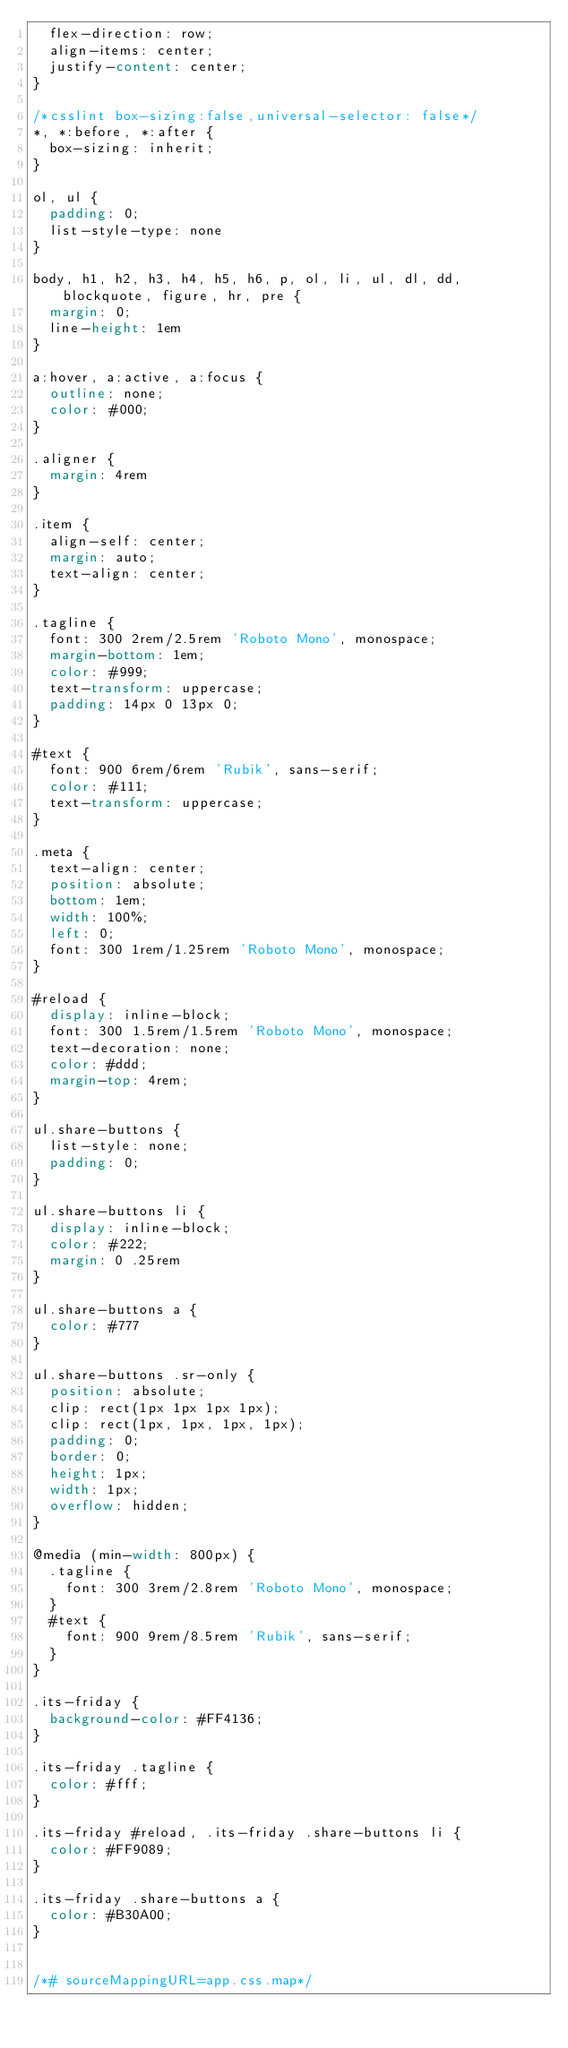<code> <loc_0><loc_0><loc_500><loc_500><_CSS_>  flex-direction: row;
  align-items: center;
  justify-content: center;
}

/*csslint box-sizing:false,universal-selector: false*/
*, *:before, *:after {
  box-sizing: inherit;
}

ol, ul {
  padding: 0;
  list-style-type: none
}

body, h1, h2, h3, h4, h5, h6, p, ol, li, ul, dl, dd, blockquote, figure, hr, pre {
  margin: 0;
  line-height: 1em
}

a:hover, a:active, a:focus {
  outline: none;
  color: #000;
}

.aligner {
  margin: 4rem
}

.item {
  align-self: center;
  margin: auto;
  text-align: center;
}

.tagline {
  font: 300 2rem/2.5rem 'Roboto Mono', monospace;
  margin-bottom: 1em;
  color: #999;
  text-transform: uppercase;
  padding: 14px 0 13px 0;
}

#text {
  font: 900 6rem/6rem 'Rubik', sans-serif;
  color: #111;
  text-transform: uppercase;
}

.meta {
  text-align: center;
  position: absolute;
  bottom: 1em;
  width: 100%;
  left: 0;
  font: 300 1rem/1.25rem 'Roboto Mono', monospace;
}

#reload {
  display: inline-block;
  font: 300 1.5rem/1.5rem 'Roboto Mono', monospace;
  text-decoration: none;
  color: #ddd;
  margin-top: 4rem;
}

ul.share-buttons {
  list-style: none;
  padding: 0;
}

ul.share-buttons li {
  display: inline-block;
  color: #222;
  margin: 0 .25rem
}

ul.share-buttons a {
  color: #777
}

ul.share-buttons .sr-only {
  position: absolute;
  clip: rect(1px 1px 1px 1px);
  clip: rect(1px, 1px, 1px, 1px);
  padding: 0;
  border: 0;
  height: 1px;
  width: 1px;
  overflow: hidden;
}

@media (min-width: 800px) {
  .tagline {
    font: 300 3rem/2.8rem 'Roboto Mono', monospace;
  }
  #text {
    font: 900 9rem/8.5rem 'Rubik', sans-serif;
  }
}

.its-friday {
  background-color: #FF4136;
}

.its-friday .tagline {
  color: #fff;
}

.its-friday #reload, .its-friday .share-buttons li {
  color: #FF9089;
}

.its-friday .share-buttons a {
  color: #B30A00;
}


/*# sourceMappingURL=app.css.map*/</code> 